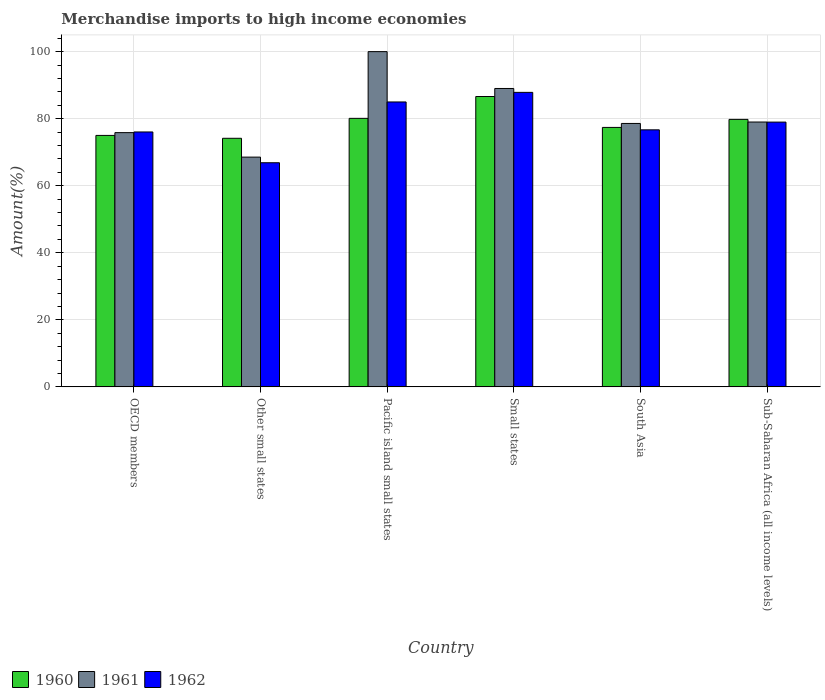How many different coloured bars are there?
Your response must be concise. 3. Are the number of bars per tick equal to the number of legend labels?
Your response must be concise. Yes. Are the number of bars on each tick of the X-axis equal?
Your answer should be compact. Yes. What is the label of the 6th group of bars from the left?
Your response must be concise. Sub-Saharan Africa (all income levels). In how many cases, is the number of bars for a given country not equal to the number of legend labels?
Provide a succinct answer. 0. What is the percentage of amount earned from merchandise imports in 1960 in Small states?
Offer a terse response. 86.61. Across all countries, what is the maximum percentage of amount earned from merchandise imports in 1962?
Your response must be concise. 87.85. Across all countries, what is the minimum percentage of amount earned from merchandise imports in 1960?
Offer a very short reply. 74.15. In which country was the percentage of amount earned from merchandise imports in 1962 maximum?
Your answer should be very brief. Small states. In which country was the percentage of amount earned from merchandise imports in 1962 minimum?
Offer a very short reply. Other small states. What is the total percentage of amount earned from merchandise imports in 1961 in the graph?
Keep it short and to the point. 490.97. What is the difference between the percentage of amount earned from merchandise imports in 1961 in Other small states and that in South Asia?
Give a very brief answer. -10.04. What is the difference between the percentage of amount earned from merchandise imports in 1960 in Pacific island small states and the percentage of amount earned from merchandise imports in 1962 in Sub-Saharan Africa (all income levels)?
Make the answer very short. 1.11. What is the average percentage of amount earned from merchandise imports in 1961 per country?
Your response must be concise. 81.83. What is the difference between the percentage of amount earned from merchandise imports of/in 1961 and percentage of amount earned from merchandise imports of/in 1960 in Other small states?
Your response must be concise. -5.62. In how many countries, is the percentage of amount earned from merchandise imports in 1962 greater than 64 %?
Make the answer very short. 6. What is the ratio of the percentage of amount earned from merchandise imports in 1960 in Small states to that in South Asia?
Keep it short and to the point. 1.12. What is the difference between the highest and the second highest percentage of amount earned from merchandise imports in 1962?
Give a very brief answer. 6.01. What is the difference between the highest and the lowest percentage of amount earned from merchandise imports in 1962?
Keep it short and to the point. 20.99. In how many countries, is the percentage of amount earned from merchandise imports in 1962 greater than the average percentage of amount earned from merchandise imports in 1962 taken over all countries?
Your answer should be very brief. 3. What does the 3rd bar from the left in Sub-Saharan Africa (all income levels) represents?
Your answer should be compact. 1962. Is it the case that in every country, the sum of the percentage of amount earned from merchandise imports in 1961 and percentage of amount earned from merchandise imports in 1960 is greater than the percentage of amount earned from merchandise imports in 1962?
Provide a succinct answer. Yes. How many bars are there?
Ensure brevity in your answer.  18. Does the graph contain grids?
Give a very brief answer. Yes. Where does the legend appear in the graph?
Give a very brief answer. Bottom left. How are the legend labels stacked?
Keep it short and to the point. Horizontal. What is the title of the graph?
Keep it short and to the point. Merchandise imports to high income economies. What is the label or title of the Y-axis?
Offer a very short reply. Amount(%). What is the Amount(%) of 1960 in OECD members?
Offer a terse response. 75.01. What is the Amount(%) in 1961 in OECD members?
Offer a very short reply. 75.84. What is the Amount(%) in 1962 in OECD members?
Offer a terse response. 76.04. What is the Amount(%) of 1960 in Other small states?
Offer a very short reply. 74.15. What is the Amount(%) in 1961 in Other small states?
Offer a very short reply. 68.53. What is the Amount(%) in 1962 in Other small states?
Provide a succinct answer. 66.86. What is the Amount(%) in 1960 in Pacific island small states?
Your answer should be very brief. 80.1. What is the Amount(%) of 1962 in Pacific island small states?
Make the answer very short. 84.99. What is the Amount(%) in 1960 in Small states?
Ensure brevity in your answer.  86.61. What is the Amount(%) of 1961 in Small states?
Offer a very short reply. 89.01. What is the Amount(%) in 1962 in Small states?
Make the answer very short. 87.85. What is the Amount(%) of 1960 in South Asia?
Your answer should be very brief. 77.39. What is the Amount(%) of 1961 in South Asia?
Keep it short and to the point. 78.58. What is the Amount(%) of 1962 in South Asia?
Make the answer very short. 76.68. What is the Amount(%) in 1960 in Sub-Saharan Africa (all income levels)?
Make the answer very short. 79.79. What is the Amount(%) in 1961 in Sub-Saharan Africa (all income levels)?
Keep it short and to the point. 79. What is the Amount(%) of 1962 in Sub-Saharan Africa (all income levels)?
Ensure brevity in your answer.  78.98. Across all countries, what is the maximum Amount(%) of 1960?
Make the answer very short. 86.61. Across all countries, what is the maximum Amount(%) of 1962?
Offer a very short reply. 87.85. Across all countries, what is the minimum Amount(%) in 1960?
Offer a very short reply. 74.15. Across all countries, what is the minimum Amount(%) of 1961?
Your response must be concise. 68.53. Across all countries, what is the minimum Amount(%) of 1962?
Your response must be concise. 66.86. What is the total Amount(%) in 1960 in the graph?
Offer a terse response. 473.06. What is the total Amount(%) in 1961 in the graph?
Ensure brevity in your answer.  490.97. What is the total Amount(%) in 1962 in the graph?
Offer a very short reply. 471.39. What is the difference between the Amount(%) in 1960 in OECD members and that in Other small states?
Offer a terse response. 0.86. What is the difference between the Amount(%) of 1961 in OECD members and that in Other small states?
Ensure brevity in your answer.  7.3. What is the difference between the Amount(%) of 1962 in OECD members and that in Other small states?
Provide a short and direct response. 9.18. What is the difference between the Amount(%) of 1960 in OECD members and that in Pacific island small states?
Make the answer very short. -5.09. What is the difference between the Amount(%) in 1961 in OECD members and that in Pacific island small states?
Provide a succinct answer. -24.16. What is the difference between the Amount(%) in 1962 in OECD members and that in Pacific island small states?
Provide a short and direct response. -8.95. What is the difference between the Amount(%) of 1960 in OECD members and that in Small states?
Keep it short and to the point. -11.6. What is the difference between the Amount(%) of 1961 in OECD members and that in Small states?
Give a very brief answer. -13.17. What is the difference between the Amount(%) in 1962 in OECD members and that in Small states?
Make the answer very short. -11.81. What is the difference between the Amount(%) of 1960 in OECD members and that in South Asia?
Give a very brief answer. -2.39. What is the difference between the Amount(%) of 1961 in OECD members and that in South Asia?
Ensure brevity in your answer.  -2.74. What is the difference between the Amount(%) in 1962 in OECD members and that in South Asia?
Provide a succinct answer. -0.64. What is the difference between the Amount(%) in 1960 in OECD members and that in Sub-Saharan Africa (all income levels)?
Offer a very short reply. -4.78. What is the difference between the Amount(%) in 1961 in OECD members and that in Sub-Saharan Africa (all income levels)?
Your answer should be very brief. -3.16. What is the difference between the Amount(%) in 1962 in OECD members and that in Sub-Saharan Africa (all income levels)?
Your answer should be compact. -2.94. What is the difference between the Amount(%) in 1960 in Other small states and that in Pacific island small states?
Make the answer very short. -5.95. What is the difference between the Amount(%) of 1961 in Other small states and that in Pacific island small states?
Offer a terse response. -31.47. What is the difference between the Amount(%) in 1962 in Other small states and that in Pacific island small states?
Provide a succinct answer. -18.13. What is the difference between the Amount(%) of 1960 in Other small states and that in Small states?
Offer a terse response. -12.46. What is the difference between the Amount(%) in 1961 in Other small states and that in Small states?
Provide a succinct answer. -20.48. What is the difference between the Amount(%) in 1962 in Other small states and that in Small states?
Your answer should be compact. -20.99. What is the difference between the Amount(%) in 1960 in Other small states and that in South Asia?
Keep it short and to the point. -3.24. What is the difference between the Amount(%) of 1961 in Other small states and that in South Asia?
Offer a terse response. -10.04. What is the difference between the Amount(%) of 1962 in Other small states and that in South Asia?
Provide a short and direct response. -9.82. What is the difference between the Amount(%) of 1960 in Other small states and that in Sub-Saharan Africa (all income levels)?
Your answer should be very brief. -5.64. What is the difference between the Amount(%) in 1961 in Other small states and that in Sub-Saharan Africa (all income levels)?
Offer a very short reply. -10.47. What is the difference between the Amount(%) of 1962 in Other small states and that in Sub-Saharan Africa (all income levels)?
Your response must be concise. -12.12. What is the difference between the Amount(%) in 1960 in Pacific island small states and that in Small states?
Offer a terse response. -6.52. What is the difference between the Amount(%) of 1961 in Pacific island small states and that in Small states?
Give a very brief answer. 10.99. What is the difference between the Amount(%) of 1962 in Pacific island small states and that in Small states?
Your answer should be very brief. -2.86. What is the difference between the Amount(%) of 1960 in Pacific island small states and that in South Asia?
Your response must be concise. 2.7. What is the difference between the Amount(%) of 1961 in Pacific island small states and that in South Asia?
Offer a very short reply. 21.42. What is the difference between the Amount(%) of 1962 in Pacific island small states and that in South Asia?
Your answer should be compact. 8.31. What is the difference between the Amount(%) of 1960 in Pacific island small states and that in Sub-Saharan Africa (all income levels)?
Your response must be concise. 0.31. What is the difference between the Amount(%) of 1961 in Pacific island small states and that in Sub-Saharan Africa (all income levels)?
Give a very brief answer. 21. What is the difference between the Amount(%) of 1962 in Pacific island small states and that in Sub-Saharan Africa (all income levels)?
Keep it short and to the point. 6.01. What is the difference between the Amount(%) of 1960 in Small states and that in South Asia?
Offer a very short reply. 9.22. What is the difference between the Amount(%) of 1961 in Small states and that in South Asia?
Make the answer very short. 10.43. What is the difference between the Amount(%) of 1962 in Small states and that in South Asia?
Your answer should be very brief. 11.18. What is the difference between the Amount(%) in 1960 in Small states and that in Sub-Saharan Africa (all income levels)?
Offer a very short reply. 6.82. What is the difference between the Amount(%) in 1961 in Small states and that in Sub-Saharan Africa (all income levels)?
Make the answer very short. 10.01. What is the difference between the Amount(%) in 1962 in Small states and that in Sub-Saharan Africa (all income levels)?
Your answer should be compact. 8.87. What is the difference between the Amount(%) in 1960 in South Asia and that in Sub-Saharan Africa (all income levels)?
Your answer should be very brief. -2.4. What is the difference between the Amount(%) in 1961 in South Asia and that in Sub-Saharan Africa (all income levels)?
Provide a short and direct response. -0.42. What is the difference between the Amount(%) of 1962 in South Asia and that in Sub-Saharan Africa (all income levels)?
Offer a terse response. -2.31. What is the difference between the Amount(%) in 1960 in OECD members and the Amount(%) in 1961 in Other small states?
Offer a very short reply. 6.47. What is the difference between the Amount(%) in 1960 in OECD members and the Amount(%) in 1962 in Other small states?
Offer a very short reply. 8.15. What is the difference between the Amount(%) of 1961 in OECD members and the Amount(%) of 1962 in Other small states?
Your response must be concise. 8.98. What is the difference between the Amount(%) in 1960 in OECD members and the Amount(%) in 1961 in Pacific island small states?
Ensure brevity in your answer.  -24.99. What is the difference between the Amount(%) in 1960 in OECD members and the Amount(%) in 1962 in Pacific island small states?
Your answer should be very brief. -9.98. What is the difference between the Amount(%) of 1961 in OECD members and the Amount(%) of 1962 in Pacific island small states?
Offer a terse response. -9.15. What is the difference between the Amount(%) in 1960 in OECD members and the Amount(%) in 1961 in Small states?
Keep it short and to the point. -14. What is the difference between the Amount(%) in 1960 in OECD members and the Amount(%) in 1962 in Small states?
Offer a very short reply. -12.84. What is the difference between the Amount(%) of 1961 in OECD members and the Amount(%) of 1962 in Small states?
Keep it short and to the point. -12.01. What is the difference between the Amount(%) in 1960 in OECD members and the Amount(%) in 1961 in South Asia?
Make the answer very short. -3.57. What is the difference between the Amount(%) in 1960 in OECD members and the Amount(%) in 1962 in South Asia?
Offer a terse response. -1.67. What is the difference between the Amount(%) of 1961 in OECD members and the Amount(%) of 1962 in South Asia?
Keep it short and to the point. -0.84. What is the difference between the Amount(%) of 1960 in OECD members and the Amount(%) of 1961 in Sub-Saharan Africa (all income levels)?
Your answer should be compact. -3.99. What is the difference between the Amount(%) of 1960 in OECD members and the Amount(%) of 1962 in Sub-Saharan Africa (all income levels)?
Your answer should be very brief. -3.97. What is the difference between the Amount(%) of 1961 in OECD members and the Amount(%) of 1962 in Sub-Saharan Africa (all income levels)?
Your response must be concise. -3.14. What is the difference between the Amount(%) of 1960 in Other small states and the Amount(%) of 1961 in Pacific island small states?
Ensure brevity in your answer.  -25.85. What is the difference between the Amount(%) of 1960 in Other small states and the Amount(%) of 1962 in Pacific island small states?
Give a very brief answer. -10.84. What is the difference between the Amount(%) in 1961 in Other small states and the Amount(%) in 1962 in Pacific island small states?
Give a very brief answer. -16.45. What is the difference between the Amount(%) in 1960 in Other small states and the Amount(%) in 1961 in Small states?
Make the answer very short. -14.86. What is the difference between the Amount(%) of 1960 in Other small states and the Amount(%) of 1962 in Small states?
Offer a terse response. -13.7. What is the difference between the Amount(%) of 1961 in Other small states and the Amount(%) of 1962 in Small states?
Make the answer very short. -19.32. What is the difference between the Amount(%) of 1960 in Other small states and the Amount(%) of 1961 in South Asia?
Ensure brevity in your answer.  -4.43. What is the difference between the Amount(%) of 1960 in Other small states and the Amount(%) of 1962 in South Asia?
Keep it short and to the point. -2.52. What is the difference between the Amount(%) in 1961 in Other small states and the Amount(%) in 1962 in South Asia?
Provide a succinct answer. -8.14. What is the difference between the Amount(%) of 1960 in Other small states and the Amount(%) of 1961 in Sub-Saharan Africa (all income levels)?
Your answer should be compact. -4.85. What is the difference between the Amount(%) in 1960 in Other small states and the Amount(%) in 1962 in Sub-Saharan Africa (all income levels)?
Offer a terse response. -4.83. What is the difference between the Amount(%) of 1961 in Other small states and the Amount(%) of 1962 in Sub-Saharan Africa (all income levels)?
Give a very brief answer. -10.45. What is the difference between the Amount(%) in 1960 in Pacific island small states and the Amount(%) in 1961 in Small states?
Your response must be concise. -8.92. What is the difference between the Amount(%) of 1960 in Pacific island small states and the Amount(%) of 1962 in Small states?
Your response must be concise. -7.75. What is the difference between the Amount(%) in 1961 in Pacific island small states and the Amount(%) in 1962 in Small states?
Your response must be concise. 12.15. What is the difference between the Amount(%) in 1960 in Pacific island small states and the Amount(%) in 1961 in South Asia?
Your answer should be compact. 1.52. What is the difference between the Amount(%) in 1960 in Pacific island small states and the Amount(%) in 1962 in South Asia?
Offer a very short reply. 3.42. What is the difference between the Amount(%) of 1961 in Pacific island small states and the Amount(%) of 1962 in South Asia?
Make the answer very short. 23.32. What is the difference between the Amount(%) in 1960 in Pacific island small states and the Amount(%) in 1961 in Sub-Saharan Africa (all income levels)?
Make the answer very short. 1.09. What is the difference between the Amount(%) of 1960 in Pacific island small states and the Amount(%) of 1962 in Sub-Saharan Africa (all income levels)?
Your answer should be compact. 1.11. What is the difference between the Amount(%) in 1961 in Pacific island small states and the Amount(%) in 1962 in Sub-Saharan Africa (all income levels)?
Your answer should be very brief. 21.02. What is the difference between the Amount(%) in 1960 in Small states and the Amount(%) in 1961 in South Asia?
Ensure brevity in your answer.  8.04. What is the difference between the Amount(%) in 1960 in Small states and the Amount(%) in 1962 in South Asia?
Your answer should be very brief. 9.94. What is the difference between the Amount(%) of 1961 in Small states and the Amount(%) of 1962 in South Asia?
Offer a very short reply. 12.34. What is the difference between the Amount(%) in 1960 in Small states and the Amount(%) in 1961 in Sub-Saharan Africa (all income levels)?
Keep it short and to the point. 7.61. What is the difference between the Amount(%) in 1960 in Small states and the Amount(%) in 1962 in Sub-Saharan Africa (all income levels)?
Keep it short and to the point. 7.63. What is the difference between the Amount(%) in 1961 in Small states and the Amount(%) in 1962 in Sub-Saharan Africa (all income levels)?
Your answer should be very brief. 10.03. What is the difference between the Amount(%) in 1960 in South Asia and the Amount(%) in 1961 in Sub-Saharan Africa (all income levels)?
Offer a terse response. -1.61. What is the difference between the Amount(%) of 1960 in South Asia and the Amount(%) of 1962 in Sub-Saharan Africa (all income levels)?
Your answer should be compact. -1.59. What is the difference between the Amount(%) of 1961 in South Asia and the Amount(%) of 1962 in Sub-Saharan Africa (all income levels)?
Provide a succinct answer. -0.4. What is the average Amount(%) in 1960 per country?
Provide a short and direct response. 78.84. What is the average Amount(%) of 1961 per country?
Keep it short and to the point. 81.83. What is the average Amount(%) in 1962 per country?
Offer a very short reply. 78.57. What is the difference between the Amount(%) in 1960 and Amount(%) in 1961 in OECD members?
Provide a succinct answer. -0.83. What is the difference between the Amount(%) in 1960 and Amount(%) in 1962 in OECD members?
Ensure brevity in your answer.  -1.03. What is the difference between the Amount(%) in 1961 and Amount(%) in 1962 in OECD members?
Give a very brief answer. -0.2. What is the difference between the Amount(%) of 1960 and Amount(%) of 1961 in Other small states?
Your response must be concise. 5.62. What is the difference between the Amount(%) in 1960 and Amount(%) in 1962 in Other small states?
Your answer should be very brief. 7.29. What is the difference between the Amount(%) of 1961 and Amount(%) of 1962 in Other small states?
Provide a short and direct response. 1.68. What is the difference between the Amount(%) of 1960 and Amount(%) of 1961 in Pacific island small states?
Give a very brief answer. -19.9. What is the difference between the Amount(%) in 1960 and Amount(%) in 1962 in Pacific island small states?
Your answer should be very brief. -4.89. What is the difference between the Amount(%) in 1961 and Amount(%) in 1962 in Pacific island small states?
Offer a very short reply. 15.01. What is the difference between the Amount(%) in 1960 and Amount(%) in 1961 in Small states?
Offer a very short reply. -2.4. What is the difference between the Amount(%) of 1960 and Amount(%) of 1962 in Small states?
Give a very brief answer. -1.24. What is the difference between the Amount(%) of 1961 and Amount(%) of 1962 in Small states?
Your answer should be compact. 1.16. What is the difference between the Amount(%) in 1960 and Amount(%) in 1961 in South Asia?
Make the answer very short. -1.18. What is the difference between the Amount(%) of 1960 and Amount(%) of 1962 in South Asia?
Provide a short and direct response. 0.72. What is the difference between the Amount(%) of 1961 and Amount(%) of 1962 in South Asia?
Keep it short and to the point. 1.9. What is the difference between the Amount(%) of 1960 and Amount(%) of 1961 in Sub-Saharan Africa (all income levels)?
Provide a succinct answer. 0.79. What is the difference between the Amount(%) of 1960 and Amount(%) of 1962 in Sub-Saharan Africa (all income levels)?
Offer a very short reply. 0.81. What is the difference between the Amount(%) in 1961 and Amount(%) in 1962 in Sub-Saharan Africa (all income levels)?
Your response must be concise. 0.02. What is the ratio of the Amount(%) of 1960 in OECD members to that in Other small states?
Give a very brief answer. 1.01. What is the ratio of the Amount(%) of 1961 in OECD members to that in Other small states?
Keep it short and to the point. 1.11. What is the ratio of the Amount(%) of 1962 in OECD members to that in Other small states?
Your answer should be compact. 1.14. What is the ratio of the Amount(%) of 1960 in OECD members to that in Pacific island small states?
Make the answer very short. 0.94. What is the ratio of the Amount(%) of 1961 in OECD members to that in Pacific island small states?
Provide a short and direct response. 0.76. What is the ratio of the Amount(%) of 1962 in OECD members to that in Pacific island small states?
Your answer should be very brief. 0.89. What is the ratio of the Amount(%) of 1960 in OECD members to that in Small states?
Offer a terse response. 0.87. What is the ratio of the Amount(%) of 1961 in OECD members to that in Small states?
Your answer should be very brief. 0.85. What is the ratio of the Amount(%) in 1962 in OECD members to that in Small states?
Your answer should be very brief. 0.87. What is the ratio of the Amount(%) of 1960 in OECD members to that in South Asia?
Ensure brevity in your answer.  0.97. What is the ratio of the Amount(%) in 1961 in OECD members to that in South Asia?
Give a very brief answer. 0.97. What is the ratio of the Amount(%) in 1960 in OECD members to that in Sub-Saharan Africa (all income levels)?
Make the answer very short. 0.94. What is the ratio of the Amount(%) in 1961 in OECD members to that in Sub-Saharan Africa (all income levels)?
Your answer should be compact. 0.96. What is the ratio of the Amount(%) in 1962 in OECD members to that in Sub-Saharan Africa (all income levels)?
Offer a very short reply. 0.96. What is the ratio of the Amount(%) in 1960 in Other small states to that in Pacific island small states?
Ensure brevity in your answer.  0.93. What is the ratio of the Amount(%) of 1961 in Other small states to that in Pacific island small states?
Keep it short and to the point. 0.69. What is the ratio of the Amount(%) in 1962 in Other small states to that in Pacific island small states?
Your answer should be compact. 0.79. What is the ratio of the Amount(%) in 1960 in Other small states to that in Small states?
Provide a short and direct response. 0.86. What is the ratio of the Amount(%) in 1961 in Other small states to that in Small states?
Your response must be concise. 0.77. What is the ratio of the Amount(%) of 1962 in Other small states to that in Small states?
Provide a succinct answer. 0.76. What is the ratio of the Amount(%) in 1960 in Other small states to that in South Asia?
Your answer should be compact. 0.96. What is the ratio of the Amount(%) in 1961 in Other small states to that in South Asia?
Provide a short and direct response. 0.87. What is the ratio of the Amount(%) of 1962 in Other small states to that in South Asia?
Provide a succinct answer. 0.87. What is the ratio of the Amount(%) in 1960 in Other small states to that in Sub-Saharan Africa (all income levels)?
Make the answer very short. 0.93. What is the ratio of the Amount(%) in 1961 in Other small states to that in Sub-Saharan Africa (all income levels)?
Give a very brief answer. 0.87. What is the ratio of the Amount(%) in 1962 in Other small states to that in Sub-Saharan Africa (all income levels)?
Provide a short and direct response. 0.85. What is the ratio of the Amount(%) of 1960 in Pacific island small states to that in Small states?
Your answer should be compact. 0.92. What is the ratio of the Amount(%) in 1961 in Pacific island small states to that in Small states?
Provide a short and direct response. 1.12. What is the ratio of the Amount(%) of 1962 in Pacific island small states to that in Small states?
Make the answer very short. 0.97. What is the ratio of the Amount(%) in 1960 in Pacific island small states to that in South Asia?
Your answer should be compact. 1.03. What is the ratio of the Amount(%) of 1961 in Pacific island small states to that in South Asia?
Your answer should be very brief. 1.27. What is the ratio of the Amount(%) in 1962 in Pacific island small states to that in South Asia?
Provide a succinct answer. 1.11. What is the ratio of the Amount(%) of 1960 in Pacific island small states to that in Sub-Saharan Africa (all income levels)?
Ensure brevity in your answer.  1. What is the ratio of the Amount(%) of 1961 in Pacific island small states to that in Sub-Saharan Africa (all income levels)?
Your response must be concise. 1.27. What is the ratio of the Amount(%) of 1962 in Pacific island small states to that in Sub-Saharan Africa (all income levels)?
Provide a short and direct response. 1.08. What is the ratio of the Amount(%) of 1960 in Small states to that in South Asia?
Give a very brief answer. 1.12. What is the ratio of the Amount(%) in 1961 in Small states to that in South Asia?
Offer a very short reply. 1.13. What is the ratio of the Amount(%) in 1962 in Small states to that in South Asia?
Provide a succinct answer. 1.15. What is the ratio of the Amount(%) of 1960 in Small states to that in Sub-Saharan Africa (all income levels)?
Make the answer very short. 1.09. What is the ratio of the Amount(%) of 1961 in Small states to that in Sub-Saharan Africa (all income levels)?
Offer a terse response. 1.13. What is the ratio of the Amount(%) in 1962 in Small states to that in Sub-Saharan Africa (all income levels)?
Your answer should be compact. 1.11. What is the ratio of the Amount(%) of 1960 in South Asia to that in Sub-Saharan Africa (all income levels)?
Give a very brief answer. 0.97. What is the ratio of the Amount(%) in 1962 in South Asia to that in Sub-Saharan Africa (all income levels)?
Provide a succinct answer. 0.97. What is the difference between the highest and the second highest Amount(%) of 1960?
Give a very brief answer. 6.52. What is the difference between the highest and the second highest Amount(%) of 1961?
Give a very brief answer. 10.99. What is the difference between the highest and the second highest Amount(%) in 1962?
Offer a very short reply. 2.86. What is the difference between the highest and the lowest Amount(%) of 1960?
Ensure brevity in your answer.  12.46. What is the difference between the highest and the lowest Amount(%) of 1961?
Your response must be concise. 31.47. What is the difference between the highest and the lowest Amount(%) of 1962?
Keep it short and to the point. 20.99. 